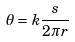Convert formula to latex. <formula><loc_0><loc_0><loc_500><loc_500>\theta = k \frac { s } { 2 \pi r }</formula> 